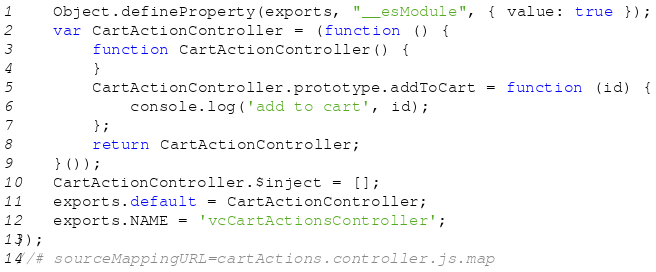<code> <loc_0><loc_0><loc_500><loc_500><_JavaScript_>    Object.defineProperty(exports, "__esModule", { value: true });
    var CartActionController = (function () {
        function CartActionController() {
        }
        CartActionController.prototype.addToCart = function (id) {
            console.log('add to cart', id);
        };
        return CartActionController;
    }());
    CartActionController.$inject = [];
    exports.default = CartActionController;
    exports.NAME = 'vcCartActionsController';
});
//# sourceMappingURL=cartActions.controller.js.map</code> 